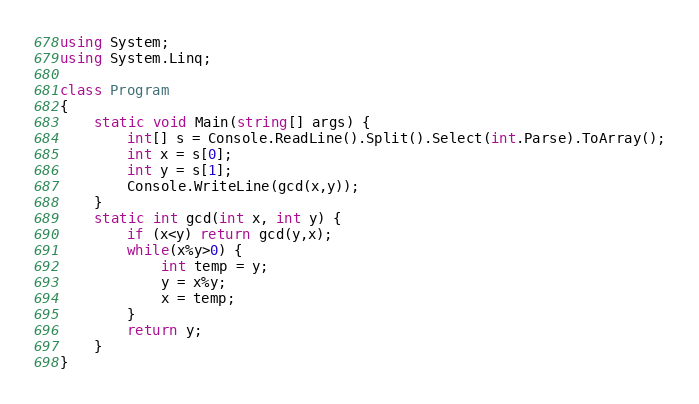Convert code to text. <code><loc_0><loc_0><loc_500><loc_500><_C#_>using System;
using System.Linq;

class Program
{
    static void Main(string[] args) {
        int[] s = Console.ReadLine().Split().Select(int.Parse).ToArray();
        int x = s[0];
        int y = s[1];
        Console.WriteLine(gcd(x,y));
    }
    static int gcd(int x, int y) {
        if (x<y) return gcd(y,x);
        while(x%y>0) {
            int temp = y;
            y = x%y;
            x = temp;
        }
        return y;
    }
}
</code> 